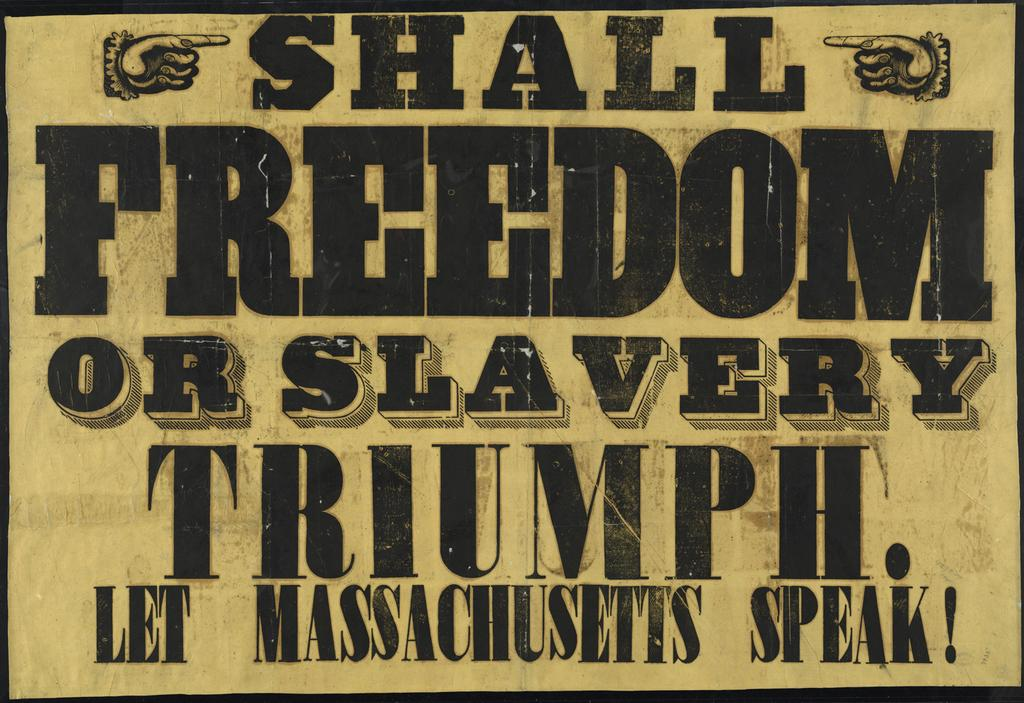<image>
Render a clear and concise summary of the photo. A sign has two hands with fingers pointing to the word shall. 